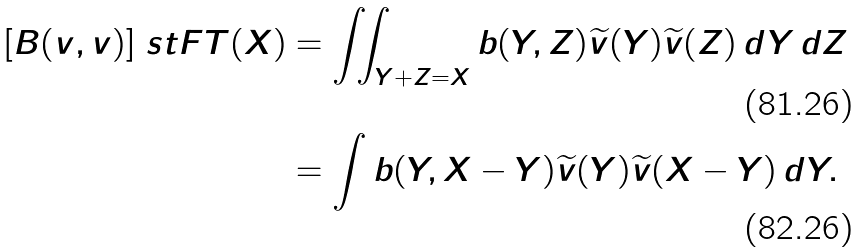<formula> <loc_0><loc_0><loc_500><loc_500>[ B ( v , v ) ] \ s t F T ( X ) & = \iint _ { Y + Z = X } b ( Y , Z ) \widetilde { v } ( Y ) \widetilde { v } ( Z ) \, d Y \, d Z \\ & = \int b ( Y , X - Y ) \widetilde { v } ( Y ) \widetilde { v } ( X - Y ) \, d Y .</formula> 